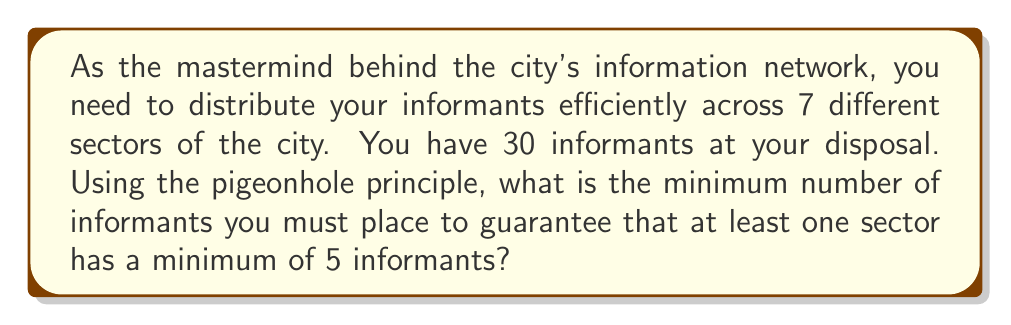Could you help me with this problem? Let's approach this step-by-step using the pigeonhole principle:

1) We have 7 sectors (pigeonholes) and 30 informants (pigeons).

2) We want to find the minimum number of informants (n) that guarantees at least one sector has 5 or more informants.

3) The pigeonhole principle states that if we have n items to distribute among m containers, and n > m * k, then at least one container must contain more than k items.

4) In our case:
   - n = the number of informants we're looking for
   - m = 7 (number of sectors)
   - k = 4 (because we want at least 5 informants in a sector, so we're looking for more than 4)

5) We can set up the inequality:
   $$ n > 7 * 4 $$

6) Solving this:
   $$ n > 28 $$

7) Since n must be an integer, the smallest value that satisfies this inequality is 29.

8) To verify:
   - If we had 28 informants, it would be possible to distribute them as 4 per sector.
   - With 29 informants, no matter how we distribute them, at least one sector must have 5 or more.

Therefore, the minimum number of informants needed is 29.
Answer: 29 informants 